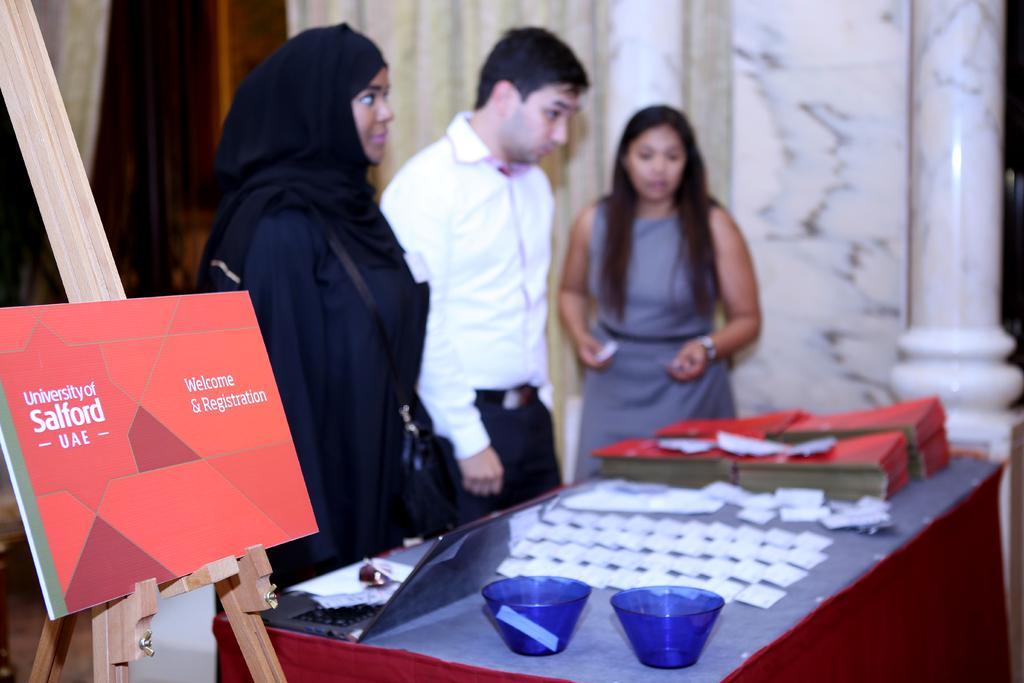In one or two sentences, can you explain what this image depicts? Here we can see three persons. This is a table. On the table there are bowls, laptop, papers, and books. There is a board. In the background we can see wall and a pillar. 